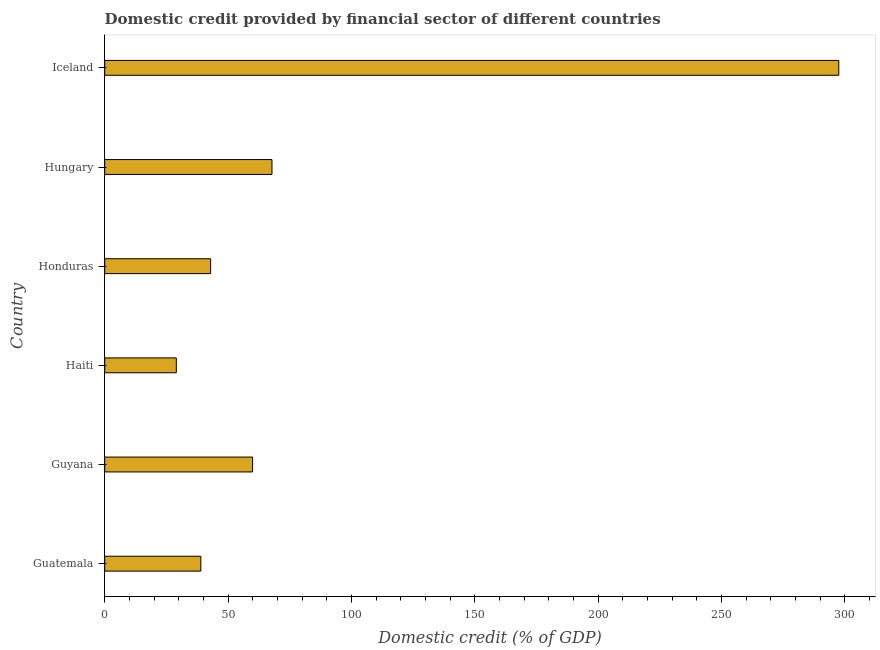Does the graph contain grids?
Provide a short and direct response. No. What is the title of the graph?
Offer a very short reply. Domestic credit provided by financial sector of different countries. What is the label or title of the X-axis?
Offer a very short reply. Domestic credit (% of GDP). What is the label or title of the Y-axis?
Make the answer very short. Country. What is the domestic credit provided by financial sector in Haiti?
Offer a terse response. 29.02. Across all countries, what is the maximum domestic credit provided by financial sector?
Provide a succinct answer. 297.59. Across all countries, what is the minimum domestic credit provided by financial sector?
Provide a short and direct response. 29.02. In which country was the domestic credit provided by financial sector minimum?
Give a very brief answer. Haiti. What is the sum of the domestic credit provided by financial sector?
Your response must be concise. 536.26. What is the difference between the domestic credit provided by financial sector in Hungary and Iceland?
Offer a terse response. -229.78. What is the average domestic credit provided by financial sector per country?
Give a very brief answer. 89.38. What is the median domestic credit provided by financial sector?
Offer a terse response. 51.44. In how many countries, is the domestic credit provided by financial sector greater than 50 %?
Provide a short and direct response. 3. What is the ratio of the domestic credit provided by financial sector in Guatemala to that in Guyana?
Make the answer very short. 0.65. Is the domestic credit provided by financial sector in Honduras less than that in Hungary?
Your answer should be compact. Yes. Is the difference between the domestic credit provided by financial sector in Guyana and Haiti greater than the difference between any two countries?
Provide a short and direct response. No. What is the difference between the highest and the second highest domestic credit provided by financial sector?
Keep it short and to the point. 229.78. What is the difference between the highest and the lowest domestic credit provided by financial sector?
Your answer should be compact. 268.56. How many bars are there?
Offer a very short reply. 6. How many countries are there in the graph?
Your answer should be very brief. 6. What is the Domestic credit (% of GDP) of Guatemala?
Ensure brevity in your answer.  38.96. What is the Domestic credit (% of GDP) in Guyana?
Ensure brevity in your answer.  59.94. What is the Domestic credit (% of GDP) in Haiti?
Your answer should be very brief. 29.02. What is the Domestic credit (% of GDP) of Honduras?
Keep it short and to the point. 42.93. What is the Domestic credit (% of GDP) in Hungary?
Ensure brevity in your answer.  67.81. What is the Domestic credit (% of GDP) of Iceland?
Offer a very short reply. 297.59. What is the difference between the Domestic credit (% of GDP) in Guatemala and Guyana?
Ensure brevity in your answer.  -20.98. What is the difference between the Domestic credit (% of GDP) in Guatemala and Haiti?
Keep it short and to the point. 9.94. What is the difference between the Domestic credit (% of GDP) in Guatemala and Honduras?
Keep it short and to the point. -3.97. What is the difference between the Domestic credit (% of GDP) in Guatemala and Hungary?
Give a very brief answer. -28.84. What is the difference between the Domestic credit (% of GDP) in Guatemala and Iceland?
Provide a short and direct response. -258.63. What is the difference between the Domestic credit (% of GDP) in Guyana and Haiti?
Your answer should be compact. 30.92. What is the difference between the Domestic credit (% of GDP) in Guyana and Honduras?
Provide a short and direct response. 17.01. What is the difference between the Domestic credit (% of GDP) in Guyana and Hungary?
Provide a short and direct response. -7.87. What is the difference between the Domestic credit (% of GDP) in Guyana and Iceland?
Make the answer very short. -237.65. What is the difference between the Domestic credit (% of GDP) in Haiti and Honduras?
Offer a very short reply. -13.91. What is the difference between the Domestic credit (% of GDP) in Haiti and Hungary?
Provide a succinct answer. -38.78. What is the difference between the Domestic credit (% of GDP) in Haiti and Iceland?
Provide a succinct answer. -268.56. What is the difference between the Domestic credit (% of GDP) in Honduras and Hungary?
Make the answer very short. -24.87. What is the difference between the Domestic credit (% of GDP) in Honduras and Iceland?
Offer a terse response. -254.66. What is the difference between the Domestic credit (% of GDP) in Hungary and Iceland?
Make the answer very short. -229.78. What is the ratio of the Domestic credit (% of GDP) in Guatemala to that in Guyana?
Offer a terse response. 0.65. What is the ratio of the Domestic credit (% of GDP) in Guatemala to that in Haiti?
Your answer should be very brief. 1.34. What is the ratio of the Domestic credit (% of GDP) in Guatemala to that in Honduras?
Your response must be concise. 0.91. What is the ratio of the Domestic credit (% of GDP) in Guatemala to that in Hungary?
Make the answer very short. 0.57. What is the ratio of the Domestic credit (% of GDP) in Guatemala to that in Iceland?
Offer a terse response. 0.13. What is the ratio of the Domestic credit (% of GDP) in Guyana to that in Haiti?
Make the answer very short. 2.06. What is the ratio of the Domestic credit (% of GDP) in Guyana to that in Honduras?
Give a very brief answer. 1.4. What is the ratio of the Domestic credit (% of GDP) in Guyana to that in Hungary?
Provide a short and direct response. 0.88. What is the ratio of the Domestic credit (% of GDP) in Guyana to that in Iceland?
Your answer should be compact. 0.2. What is the ratio of the Domestic credit (% of GDP) in Haiti to that in Honduras?
Keep it short and to the point. 0.68. What is the ratio of the Domestic credit (% of GDP) in Haiti to that in Hungary?
Your answer should be very brief. 0.43. What is the ratio of the Domestic credit (% of GDP) in Haiti to that in Iceland?
Provide a short and direct response. 0.1. What is the ratio of the Domestic credit (% of GDP) in Honduras to that in Hungary?
Your answer should be very brief. 0.63. What is the ratio of the Domestic credit (% of GDP) in Honduras to that in Iceland?
Make the answer very short. 0.14. What is the ratio of the Domestic credit (% of GDP) in Hungary to that in Iceland?
Make the answer very short. 0.23. 